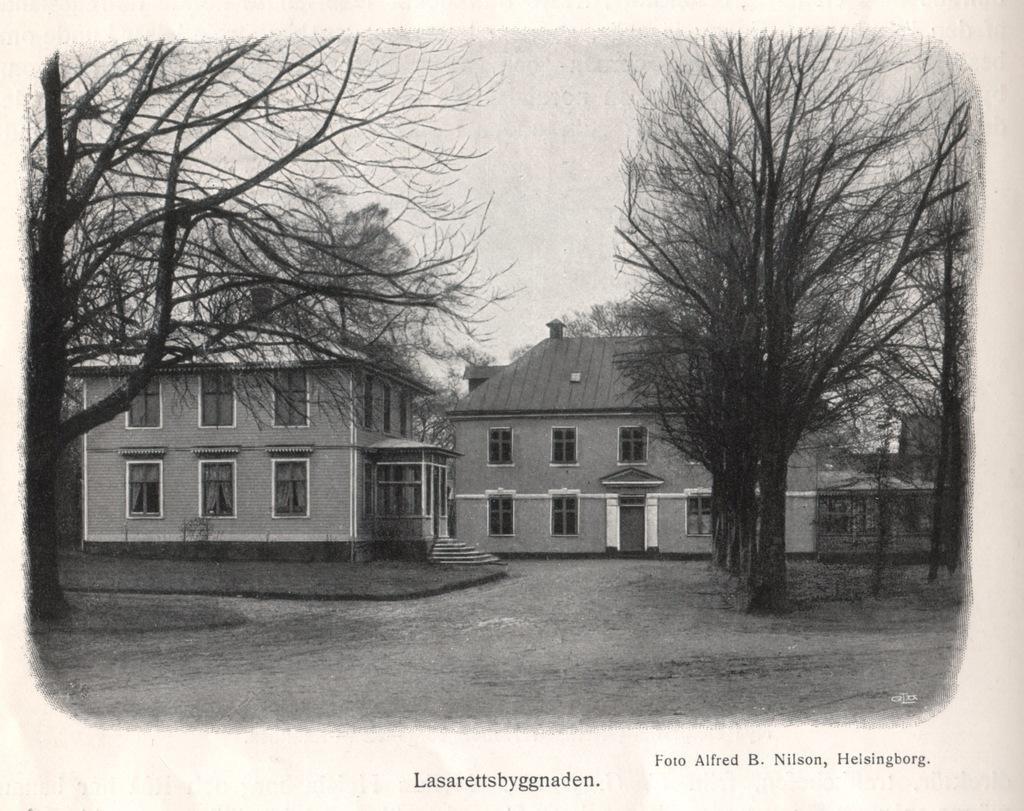In one or two sentences, can you explain what this image depicts? This is a black and white picture. In the foreground of the picture there are trees. In the center of the picture there are buildings and grass. In the background there are trees. At the bottom there is text. 